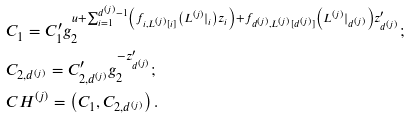Convert formula to latex. <formula><loc_0><loc_0><loc_500><loc_500>& C _ { 1 } = C ^ { \prime } _ { 1 } g _ { 2 } ^ { u + \sum _ { i = 1 } ^ { d ^ { ( j ) } - 1 } \left ( f _ { i , L ^ { ( j ) } [ i ] } \left ( L ^ { ( j ) } | _ { i } \right ) z _ { i } \right ) + f _ { d ^ { ( j ) } , L ^ { ( j ) } [ d ^ { ( j ) } ] } \left ( L ^ { ( j ) } | _ { d ^ { ( j ) } } \right ) z ^ { \prime } _ { d ^ { ( j ) } } } ; & \\ & C _ { 2 , d ^ { ( j ) } } = C ^ { \prime } _ { 2 , d ^ { ( j ) } } g _ { 2 } ^ { - z ^ { \prime } _ { d ^ { ( j ) } } } ; \\ & C H ^ { ( j ) } = \left ( C _ { 1 } , C _ { 2 , d ^ { ( j ) } } \right ) .</formula> 